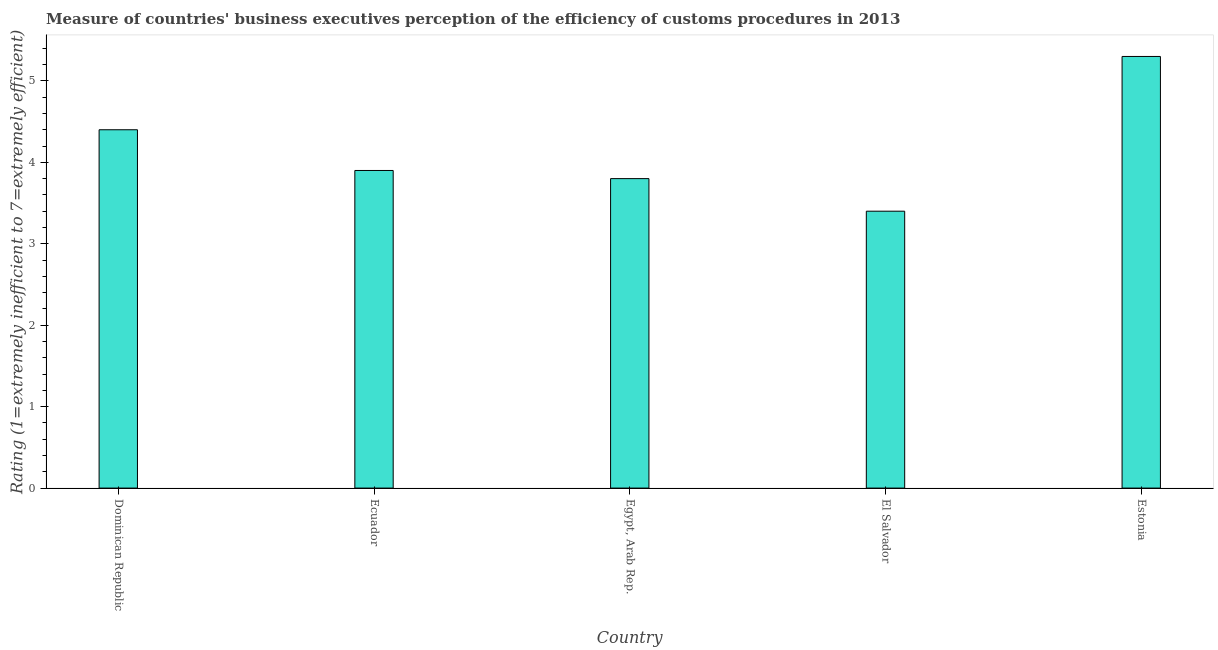Does the graph contain any zero values?
Your answer should be very brief. No. What is the title of the graph?
Your answer should be compact. Measure of countries' business executives perception of the efficiency of customs procedures in 2013. What is the label or title of the Y-axis?
Your response must be concise. Rating (1=extremely inefficient to 7=extremely efficient). Across all countries, what is the minimum rating measuring burden of customs procedure?
Your answer should be compact. 3.4. In which country was the rating measuring burden of customs procedure maximum?
Offer a very short reply. Estonia. In which country was the rating measuring burden of customs procedure minimum?
Ensure brevity in your answer.  El Salvador. What is the sum of the rating measuring burden of customs procedure?
Give a very brief answer. 20.8. What is the difference between the rating measuring burden of customs procedure in Dominican Republic and Ecuador?
Your answer should be compact. 0.5. What is the average rating measuring burden of customs procedure per country?
Provide a short and direct response. 4.16. What is the ratio of the rating measuring burden of customs procedure in Dominican Republic to that in El Salvador?
Provide a short and direct response. 1.29. Is the rating measuring burden of customs procedure in Ecuador less than that in El Salvador?
Provide a succinct answer. No. Is the sum of the rating measuring burden of customs procedure in Dominican Republic and El Salvador greater than the maximum rating measuring burden of customs procedure across all countries?
Offer a terse response. Yes. Are all the bars in the graph horizontal?
Ensure brevity in your answer.  No. What is the difference between two consecutive major ticks on the Y-axis?
Offer a very short reply. 1. What is the Rating (1=extremely inefficient to 7=extremely efficient) of Egypt, Arab Rep.?
Your answer should be very brief. 3.8. What is the Rating (1=extremely inefficient to 7=extremely efficient) of El Salvador?
Your response must be concise. 3.4. What is the difference between the Rating (1=extremely inefficient to 7=extremely efficient) in Dominican Republic and El Salvador?
Provide a succinct answer. 1. What is the difference between the Rating (1=extremely inefficient to 7=extremely efficient) in Dominican Republic and Estonia?
Make the answer very short. -0.9. What is the difference between the Rating (1=extremely inefficient to 7=extremely efficient) in Ecuador and El Salvador?
Provide a short and direct response. 0.5. What is the difference between the Rating (1=extremely inefficient to 7=extremely efficient) in Egypt, Arab Rep. and El Salvador?
Make the answer very short. 0.4. What is the ratio of the Rating (1=extremely inefficient to 7=extremely efficient) in Dominican Republic to that in Ecuador?
Provide a short and direct response. 1.13. What is the ratio of the Rating (1=extremely inefficient to 7=extremely efficient) in Dominican Republic to that in Egypt, Arab Rep.?
Ensure brevity in your answer.  1.16. What is the ratio of the Rating (1=extremely inefficient to 7=extremely efficient) in Dominican Republic to that in El Salvador?
Provide a succinct answer. 1.29. What is the ratio of the Rating (1=extremely inefficient to 7=extremely efficient) in Dominican Republic to that in Estonia?
Ensure brevity in your answer.  0.83. What is the ratio of the Rating (1=extremely inefficient to 7=extremely efficient) in Ecuador to that in Egypt, Arab Rep.?
Ensure brevity in your answer.  1.03. What is the ratio of the Rating (1=extremely inefficient to 7=extremely efficient) in Ecuador to that in El Salvador?
Provide a succinct answer. 1.15. What is the ratio of the Rating (1=extremely inefficient to 7=extremely efficient) in Ecuador to that in Estonia?
Offer a very short reply. 0.74. What is the ratio of the Rating (1=extremely inefficient to 7=extremely efficient) in Egypt, Arab Rep. to that in El Salvador?
Give a very brief answer. 1.12. What is the ratio of the Rating (1=extremely inefficient to 7=extremely efficient) in Egypt, Arab Rep. to that in Estonia?
Give a very brief answer. 0.72. What is the ratio of the Rating (1=extremely inefficient to 7=extremely efficient) in El Salvador to that in Estonia?
Give a very brief answer. 0.64. 